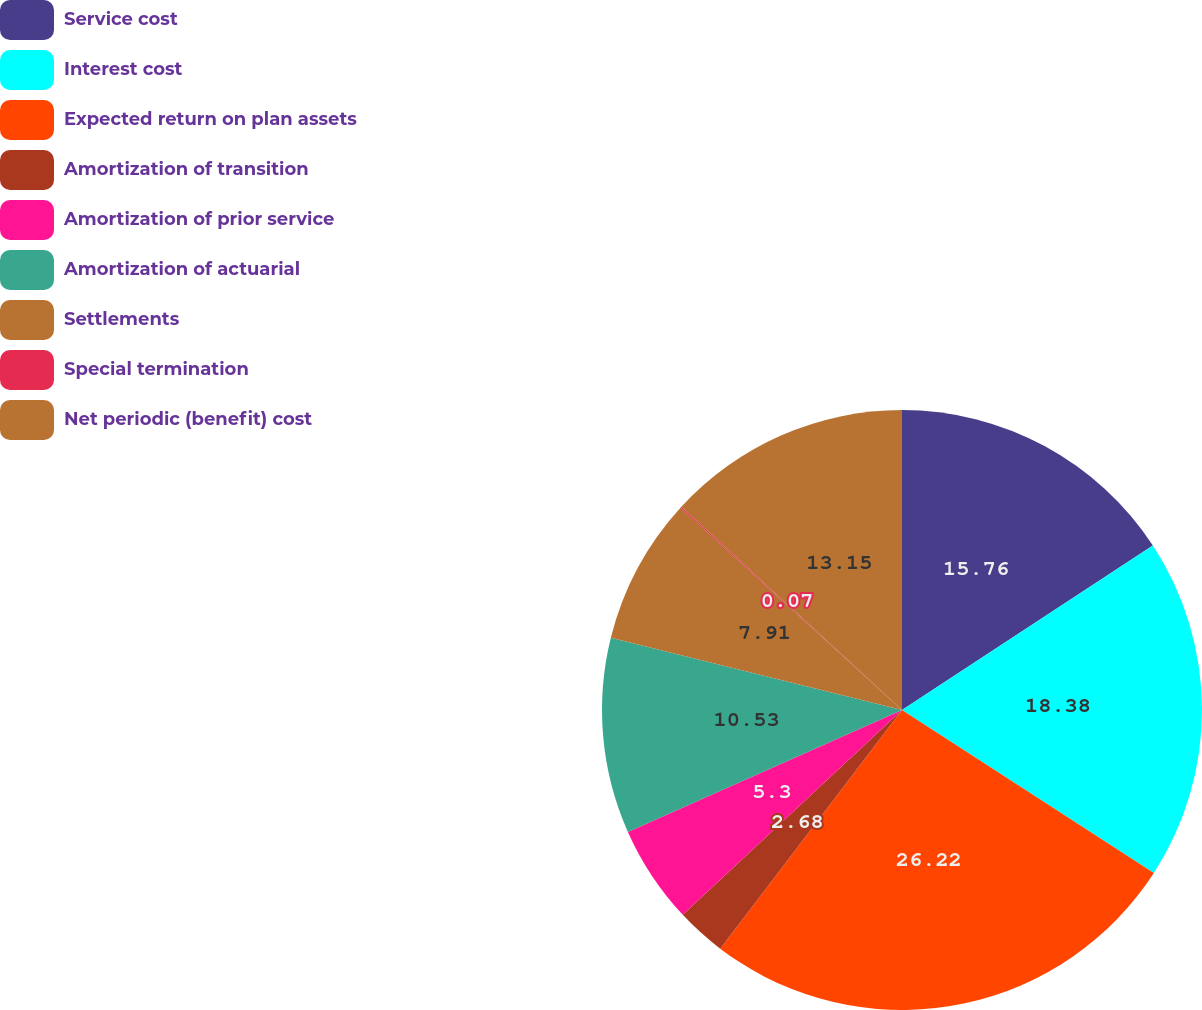Convert chart to OTSL. <chart><loc_0><loc_0><loc_500><loc_500><pie_chart><fcel>Service cost<fcel>Interest cost<fcel>Expected return on plan assets<fcel>Amortization of transition<fcel>Amortization of prior service<fcel>Amortization of actuarial<fcel>Settlements<fcel>Special termination<fcel>Net periodic (benefit) cost<nl><fcel>15.76%<fcel>18.38%<fcel>26.22%<fcel>2.68%<fcel>5.3%<fcel>10.53%<fcel>7.91%<fcel>0.07%<fcel>13.15%<nl></chart> 